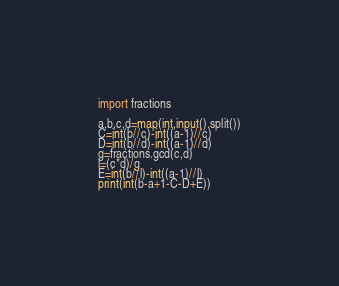<code> <loc_0><loc_0><loc_500><loc_500><_Python_>import fractions

a,b,c,d=map(int,input().split())
C=int(b//c)-int((a-1)//c)
D=int(b//d)-int((a-1)//d)
g=fractions.gcd(c,d)
l=(c*d)/g
E=int(b//l)-int((a-1)//l)
print(int(b-a+1-C-D+E))

</code> 